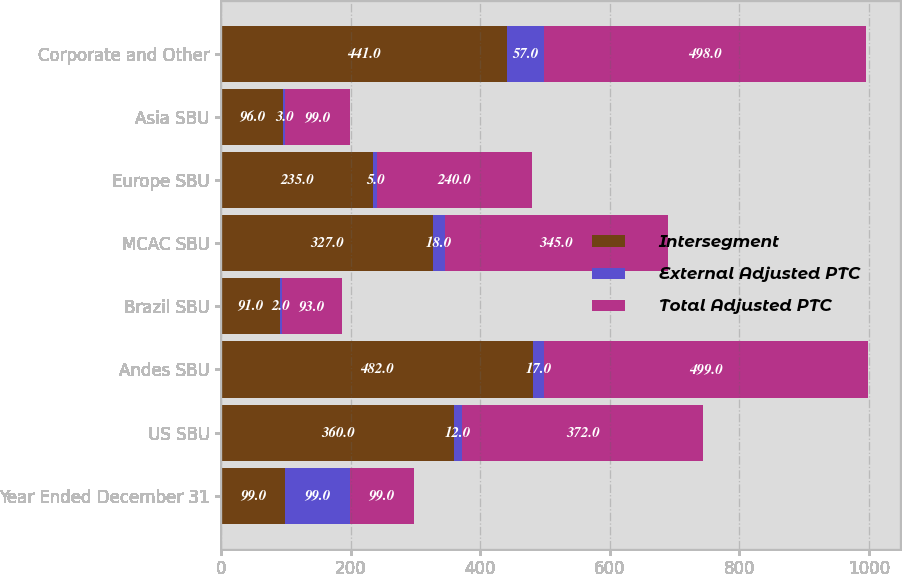Convert chart to OTSL. <chart><loc_0><loc_0><loc_500><loc_500><stacked_bar_chart><ecel><fcel>Year Ended December 31<fcel>US SBU<fcel>Andes SBU<fcel>Brazil SBU<fcel>MCAC SBU<fcel>Europe SBU<fcel>Asia SBU<fcel>Corporate and Other<nl><fcel>Intersegment<fcel>99<fcel>360<fcel>482<fcel>91<fcel>327<fcel>235<fcel>96<fcel>441<nl><fcel>External Adjusted PTC<fcel>99<fcel>12<fcel>17<fcel>2<fcel>18<fcel>5<fcel>3<fcel>57<nl><fcel>Total Adjusted PTC<fcel>99<fcel>372<fcel>499<fcel>93<fcel>345<fcel>240<fcel>99<fcel>498<nl></chart> 